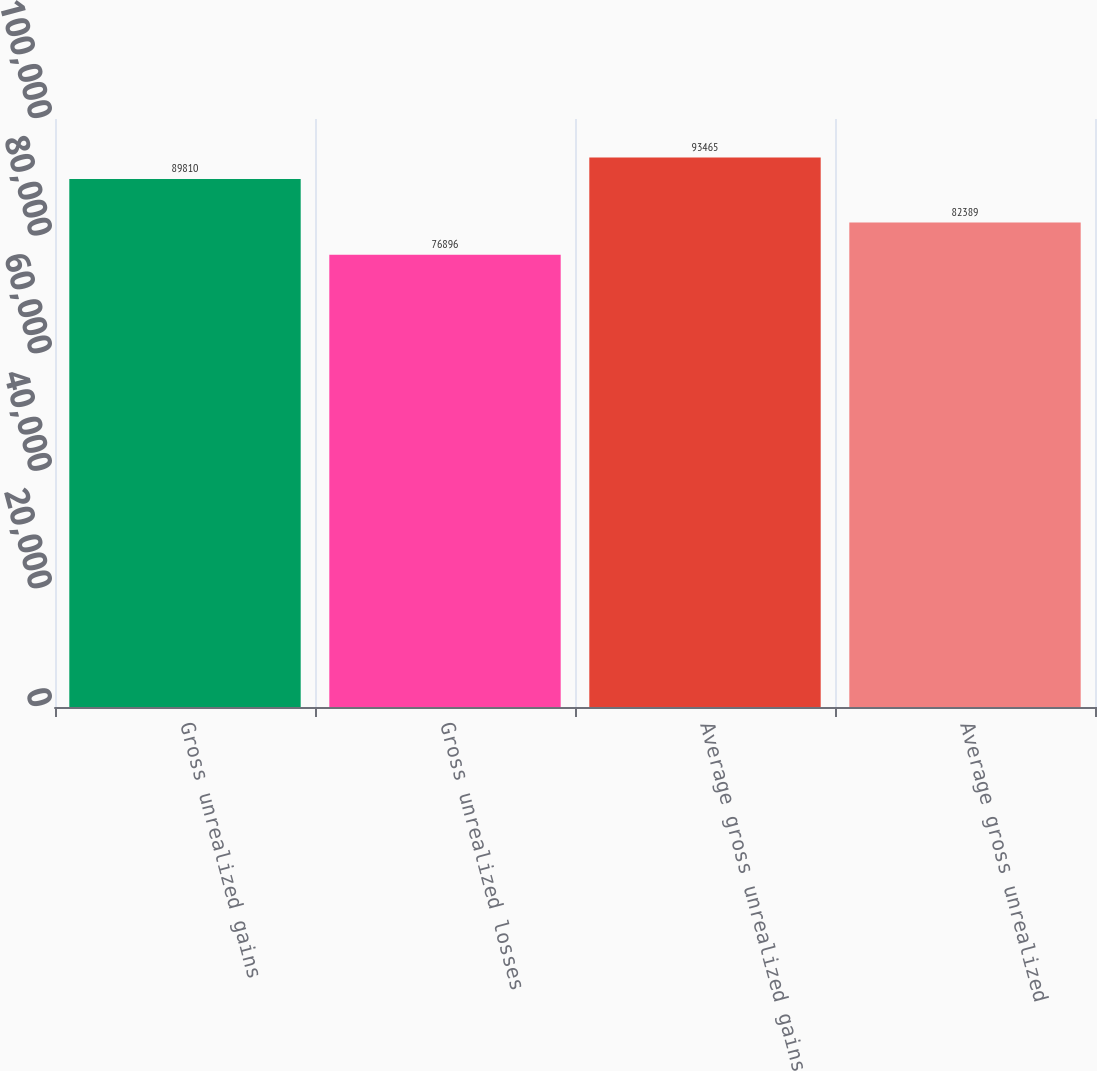Convert chart. <chart><loc_0><loc_0><loc_500><loc_500><bar_chart><fcel>Gross unrealized gains<fcel>Gross unrealized losses<fcel>Average gross unrealized gains<fcel>Average gross unrealized<nl><fcel>89810<fcel>76896<fcel>93465<fcel>82389<nl></chart> 